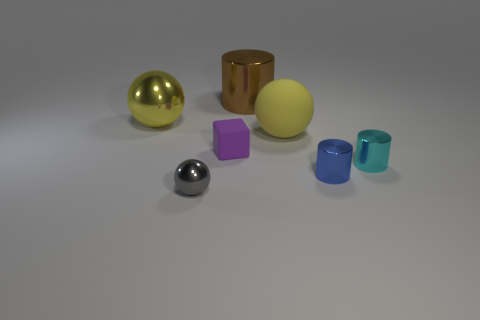Subtract all small metallic cylinders. How many cylinders are left? 1 Subtract all red blocks. How many yellow balls are left? 2 Subtract 1 cylinders. How many cylinders are left? 2 Add 1 gray metallic things. How many objects exist? 8 Subtract all blue balls. Subtract all brown cylinders. How many balls are left? 3 Subtract all balls. How many objects are left? 4 Subtract 0 red cubes. How many objects are left? 7 Subtract all cyan metallic cylinders. Subtract all tiny gray metallic spheres. How many objects are left? 5 Add 6 balls. How many balls are left? 9 Add 2 small shiny cylinders. How many small shiny cylinders exist? 4 